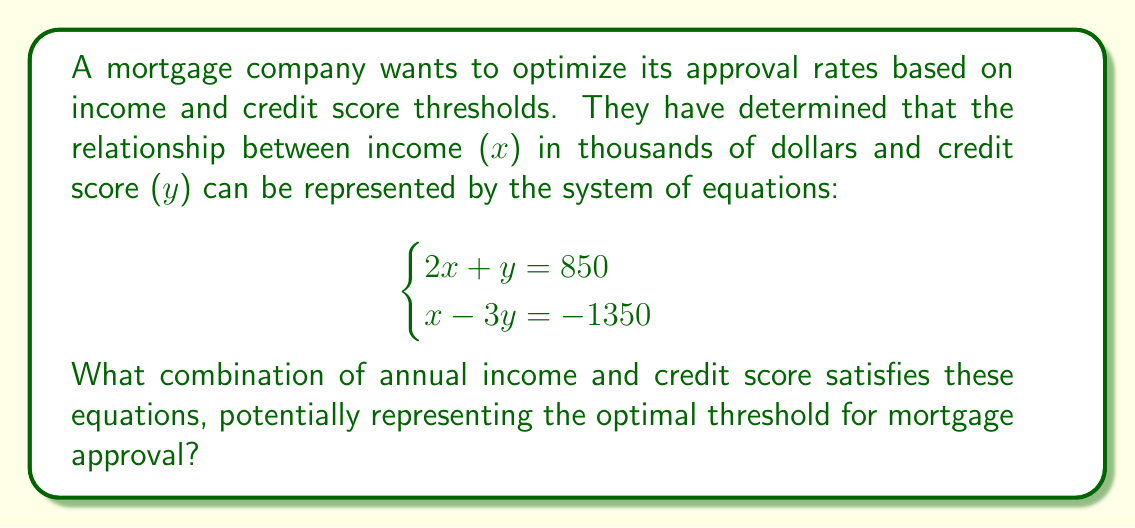Solve this math problem. To solve this system of equations, we'll use the substitution method:

1) From the first equation, express $y$ in terms of $x$:
   $$2x + y = 850$$
   $$y = 850 - 2x$$

2) Substitute this expression for $y$ into the second equation:
   $$x - 3(850 - 2x) = -1350$$

3) Simplify:
   $$x - 2550 + 6x = -1350$$
   $$7x - 2550 = -1350$$

4) Solve for $x$:
   $$7x = -1350 + 2550$$
   $$7x = 1200$$
   $$x = \frac{1200}{7} \approx 171.43$$

5) Round $x$ to the nearest whole number: $x = 171$

6) Substitute this value of $x$ back into the equation from step 1 to find $y$:
   $$y = 850 - 2(171)$$
   $$y = 850 - 342 = 508$$

Therefore, the optimal threshold for mortgage approval based on this system would be an annual income of $171,000 and a credit score of 508.
Answer: $171,000 annual income, 508 credit score 